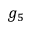Convert formula to latex. <formula><loc_0><loc_0><loc_500><loc_500>g _ { 5 }</formula> 